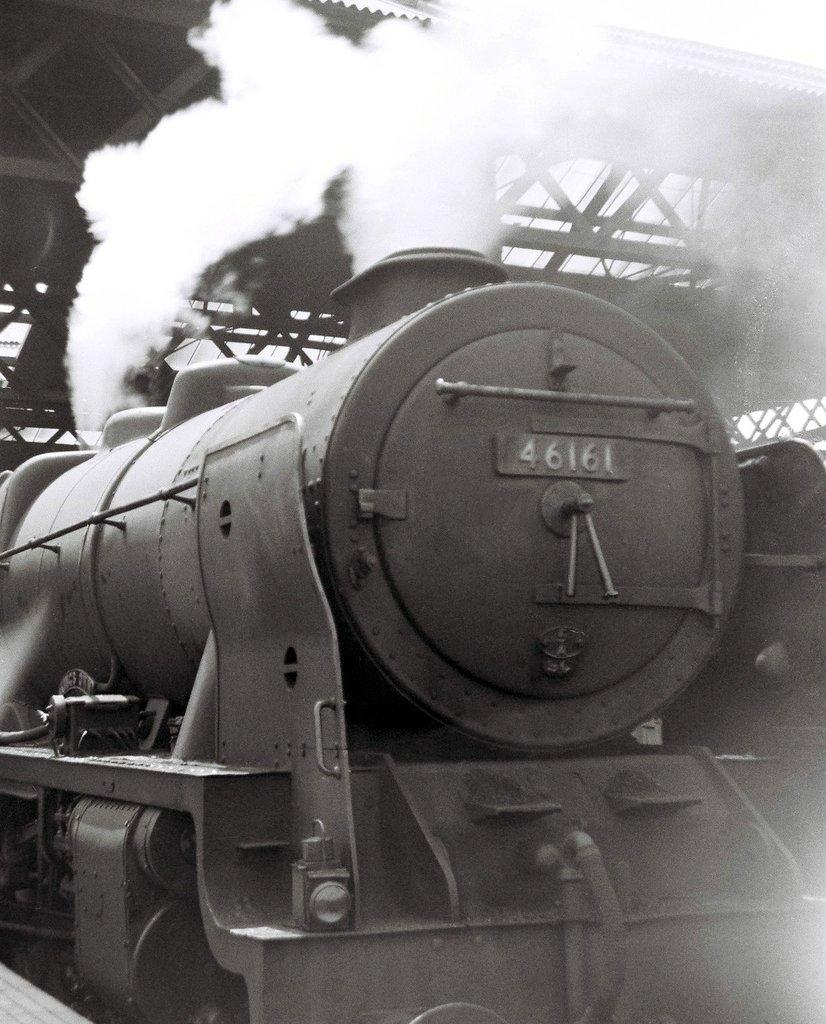What is the color scheme of the image? The image is black and white. What is the main subject of the image? There is a train engine in the image. What can be seen coming out of the train engine? Smoke is visible in the image. What type of structure is present in the image? There is a foot over bridge in the image. What type of lamp is hanging from the train engine in the image? There is no lamp hanging from the train engine in the image. What is the quill used for in the image? There is no quill present in the image. 